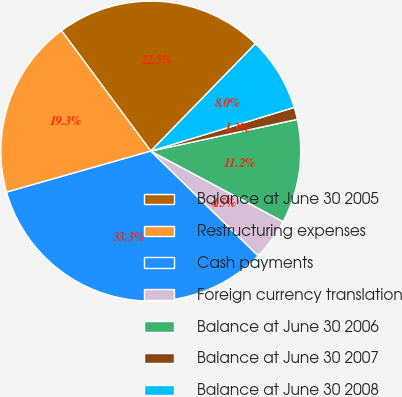<chart> <loc_0><loc_0><loc_500><loc_500><pie_chart><fcel>Balance at June 30 2005<fcel>Restructuring expenses<fcel>Cash payments<fcel>Foreign currency translation<fcel>Balance at June 30 2006<fcel>Balance at June 30 2007<fcel>Balance at June 30 2008<nl><fcel>22.45%<fcel>19.26%<fcel>33.29%<fcel>4.5%<fcel>11.19%<fcel>1.31%<fcel>8.0%<nl></chart> 